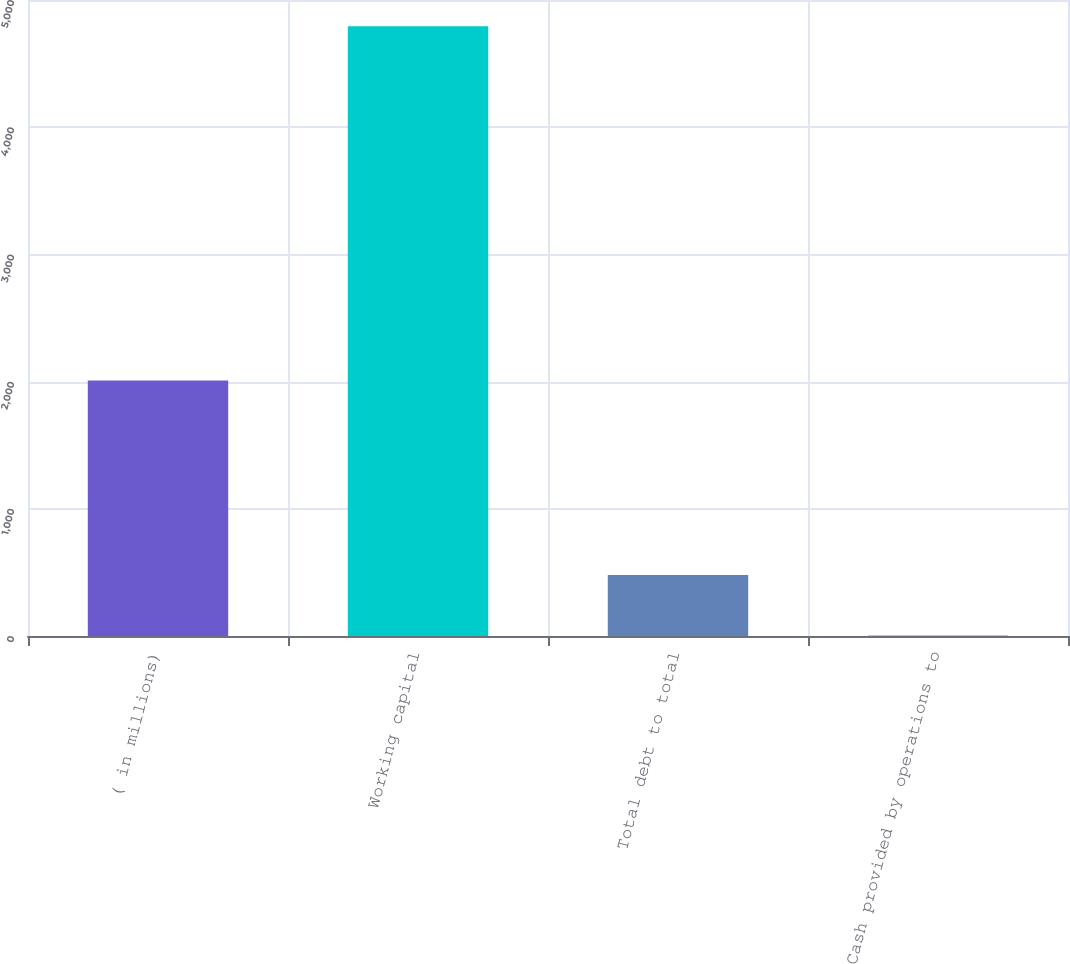Convert chart to OTSL. <chart><loc_0><loc_0><loc_500><loc_500><bar_chart><fcel>( in millions)<fcel>Working capital<fcel>Total debt to total<fcel>Cash provided by operations to<nl><fcel>2008<fcel>4794<fcel>480.4<fcel>1.11<nl></chart> 